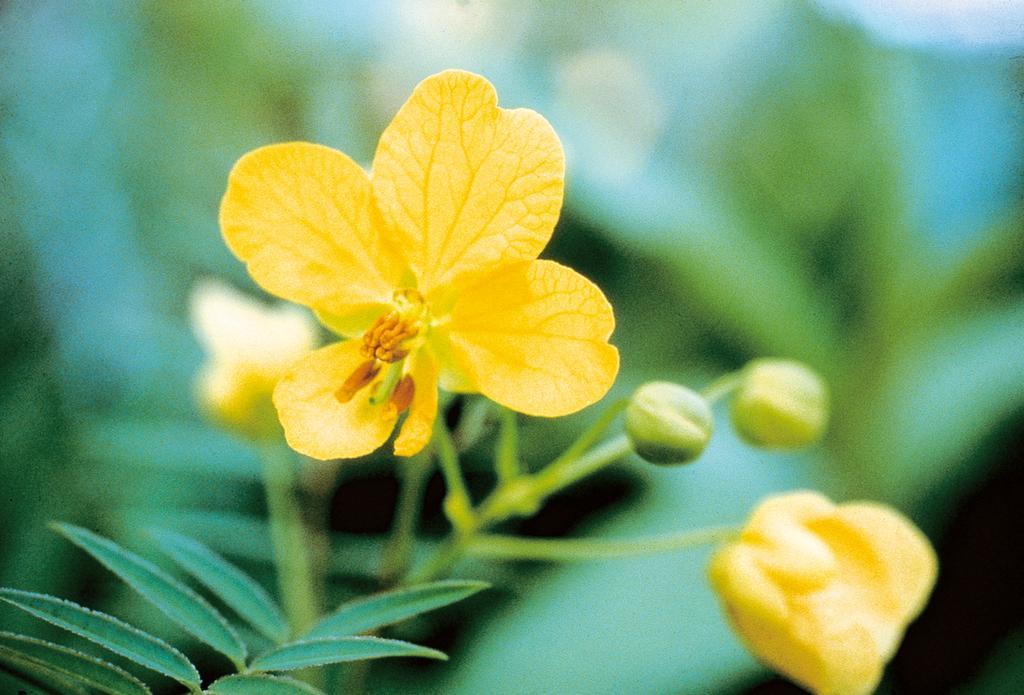How would you summarize this image in a sentence or two? In the picture we can see a plant with some flowers and flower buds and the flowers are yellow in color and behind it also we can see some plants which are not clearly visible. 